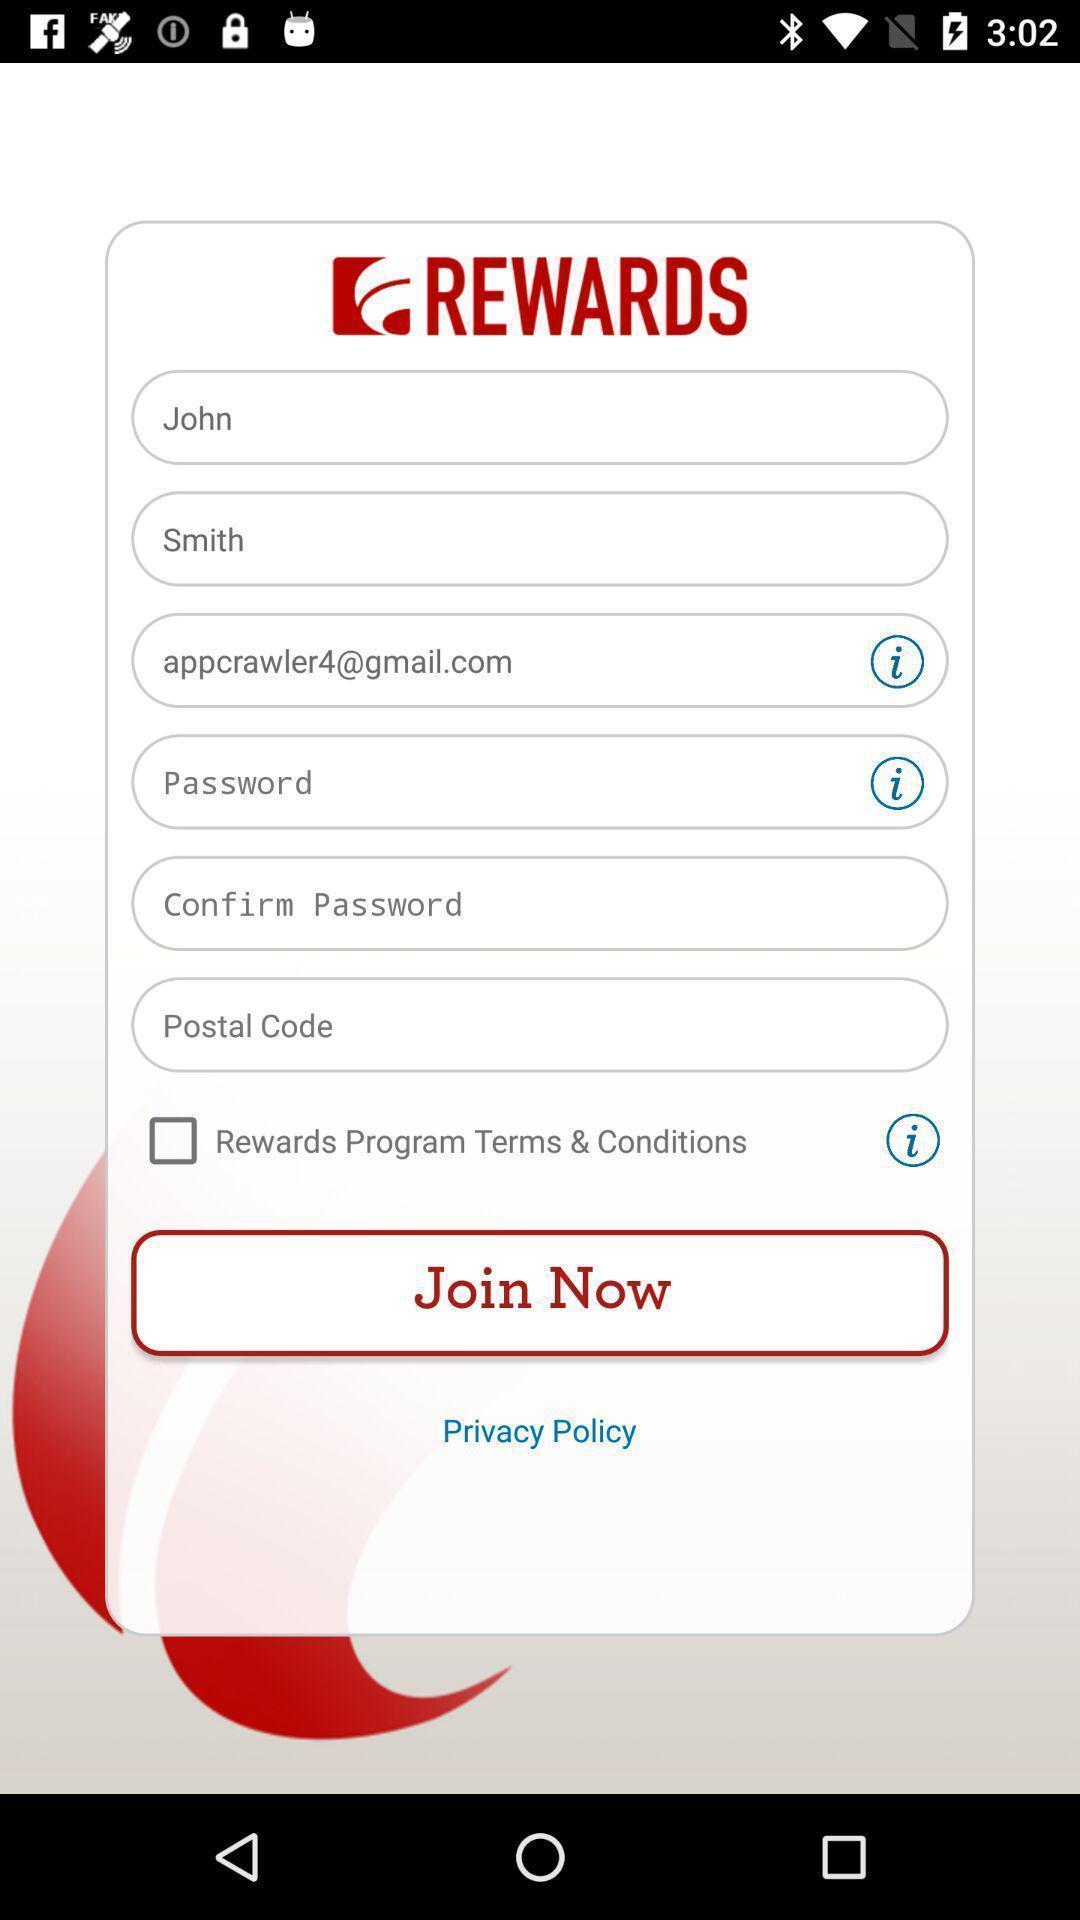Tell me what you see in this picture. Starting page to join the footwear app. 